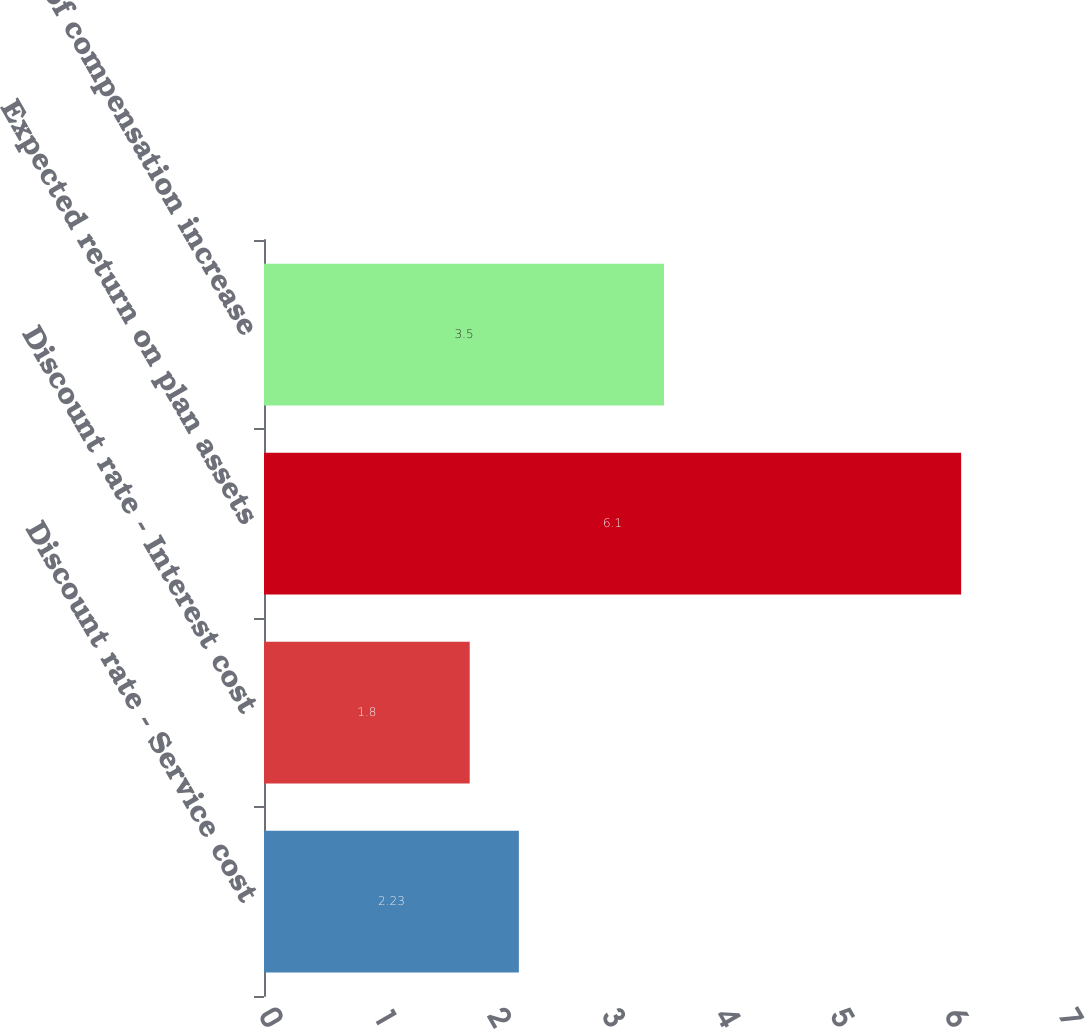Convert chart to OTSL. <chart><loc_0><loc_0><loc_500><loc_500><bar_chart><fcel>Discount rate - Service cost<fcel>Discount rate - Interest cost<fcel>Expected return on plan assets<fcel>Rate of compensation increase<nl><fcel>2.23<fcel>1.8<fcel>6.1<fcel>3.5<nl></chart> 